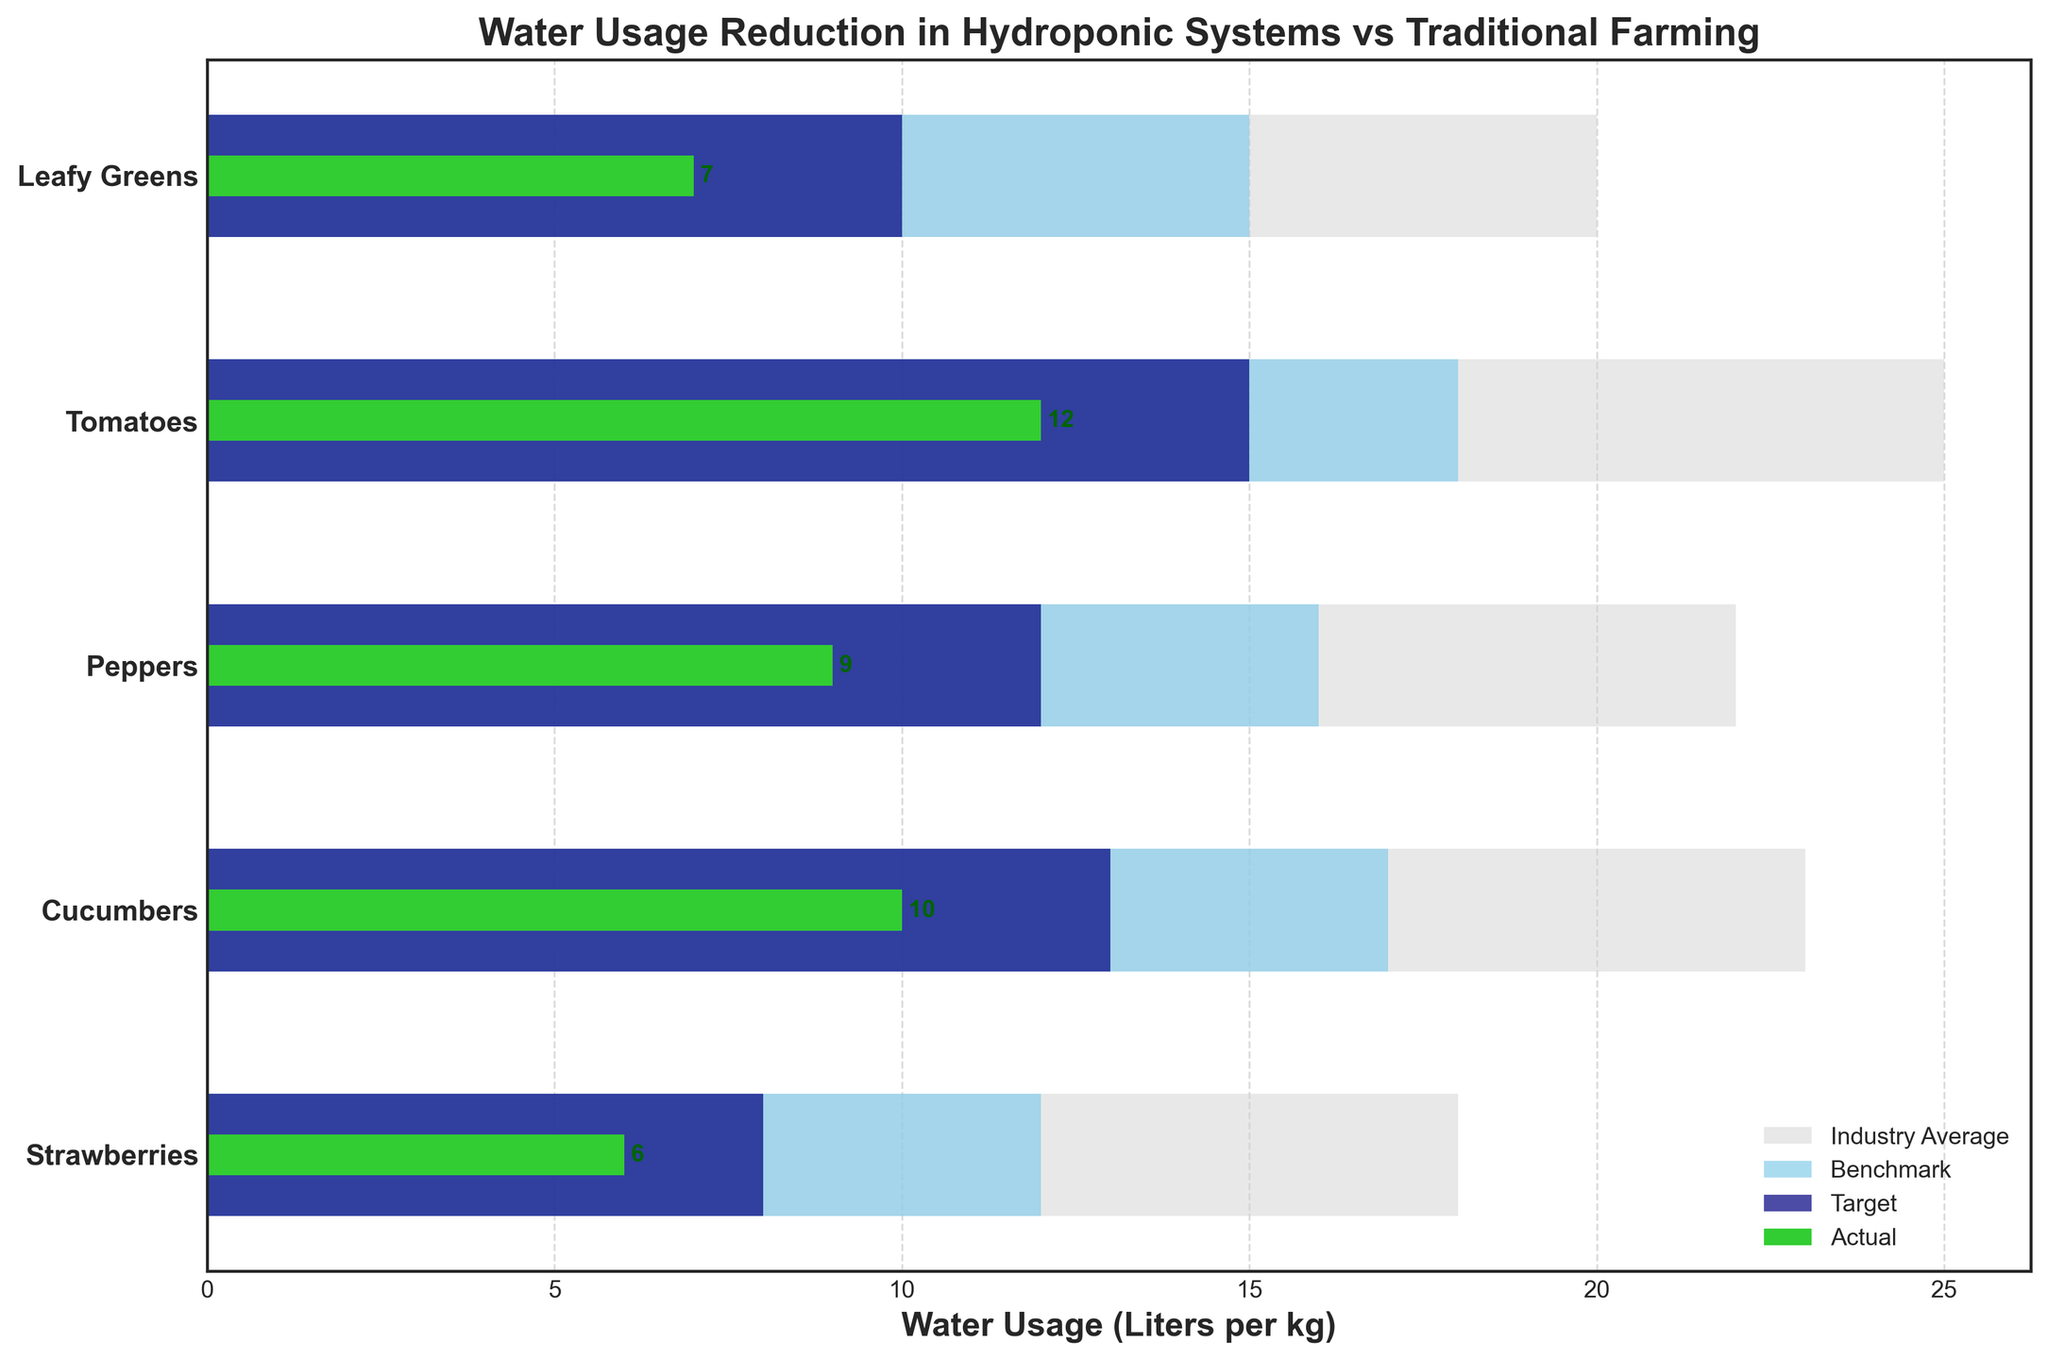What is the title of the figure? The title is written clearly at the top of the figure, and it serves as a summary of what the chart is about.
Answer: Water Usage Reduction in Hydroponic Systems vs Traditional Farming What categories are displayed on the Y-axis? The categories are labeled on the Y-axis, and they represent different types of crops.
Answer: Leafy Greens, Tomatoes, Peppers, Cucumbers, Strawberries Which category has the lowest actual water usage? Finding the shortest green bar shows the category with the least actual water usage in the chart.
Answer: Strawberries What does the light grey bar represent? The legend explains what each color represents, and light grey is used consistently across categories.
Answer: Industry Average How many categories have actual water usage below their target? Comparing each green bar (actual) to the navy blue bar (target) for each category will give the answer.
Answer: All categories What is the difference between actual and target water usage for Tomatoes? Subtract the length of the green bar (actual) from the navy blue bar (target) for the Tomatoes category.
Answer: 3 liters per kg (15 - 12) Are there any categories where actual water usage is higher than the benchmark? By comparing the green bar (actual) to the sky blue bar (benchmark) for each category, this can be determined.
Answer: No Which category exhibits the largest reduction in water usage when comparing actual to industry average? The largest gap between the green bar (actual) and the light grey bar (industry average) indicates the largest reduction.
Answer: Strawberries (18 - 6 = 12 liters per kg) How does the water usage for Cucumbers compare against the benchmark and industry average? The comparison involves checking the lengths of the bars for Cucumbers: actual (green), benchmark (sky blue), and industry average (light grey).
Answer: Actual: 10, Benchmark: 17, Industry Average: 23 (Actual is less than both) What is the combined target water usage for Peppers and Cucumbers? Add the target values from the navy blue bars for both Peppers and Cucumbers.
Answer: 25 liters per kg (12 + 13) 